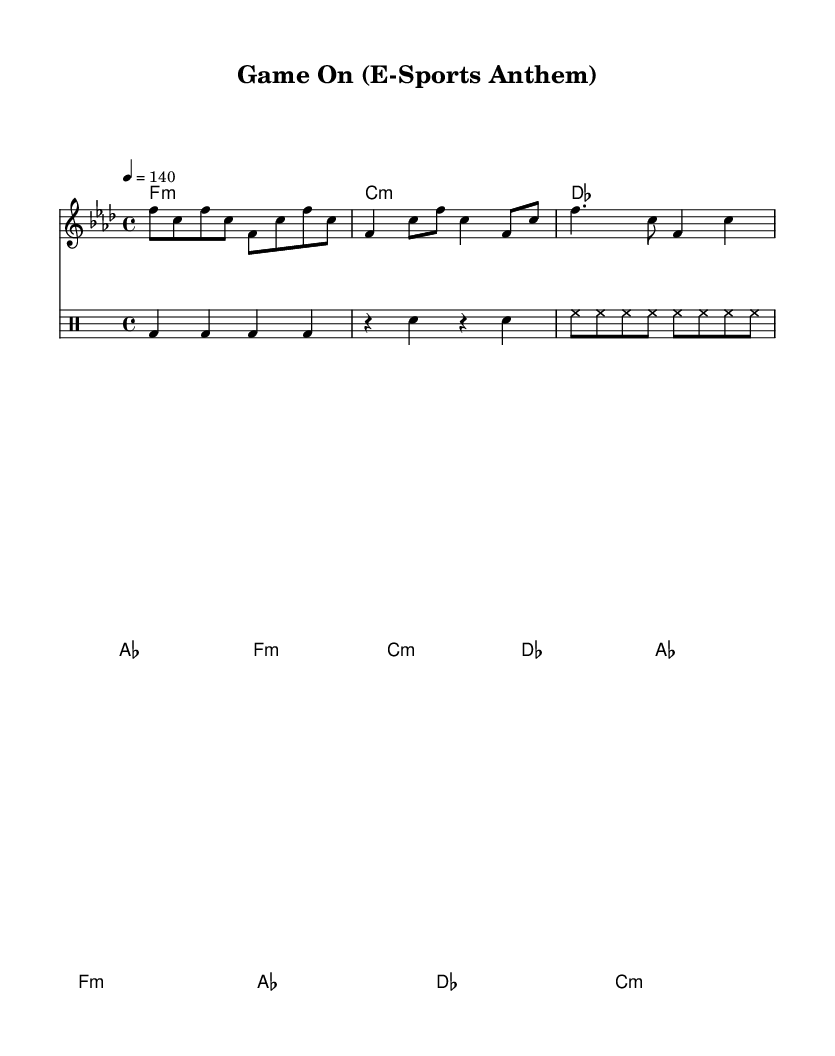What is the key signature of this music? The key signature is F minor, which has four flats: B♭, E♭, A♭, and D♭.
Answer: F minor What is the time signature of this music? The time signature is indicated as 4/4, meaning there are four beats per measure and a quarter note receives one beat.
Answer: 4/4 What is the tempo marking for this piece? The tempo marking is quarter note equals 140, indicating the speed at which the music should be played, specifically that there are 140 quarter note beats in a minute.
Answer: 140 What type of melody is mostly used in the chorus? The chorus employs a repeated pattern that features a mix of quarter notes and eighth notes, typical for energetic sections in rap music that aim to elevate intensity.
Answer: Repeated pattern How many measures are in the intro of the music? The intro consists of four distinct measures, each having different notes played in a rhythmic sequence that leads into the verse.
Answer: 4 What style of rhythm is primarily used throughout the piece? The rhythm primarily uses a driving, energetic drum pattern with kick, snare, and hi-hat, typical in high-energy rap music, which maintains the intensity needed for gaming sessions.
Answer: Energetic drum pattern How do the harmonies in the verse complement the melody? The harmonies in the verse are structured to match the chord changes in the melody, creating a strong foundation that supports the rap lyrics' vocal delivery, enhancing the overall intensity.
Answer: Match chord changes 